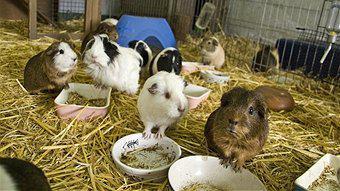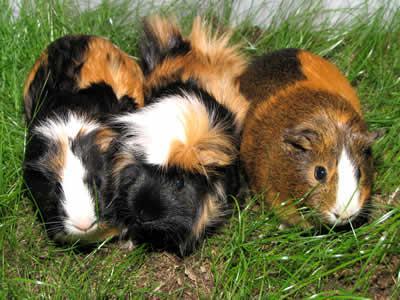The first image is the image on the left, the second image is the image on the right. Given the left and right images, does the statement "An image shows a horizontal row of no more than five hamsters." hold true? Answer yes or no. Yes. The first image is the image on the left, the second image is the image on the right. For the images shown, is this caption "At least one image shows guinea pigs lined up on three steps." true? Answer yes or no. No. The first image is the image on the left, the second image is the image on the right. Considering the images on both sides, is "There are no more than five animals in one of the images" valid? Answer yes or no. Yes. 